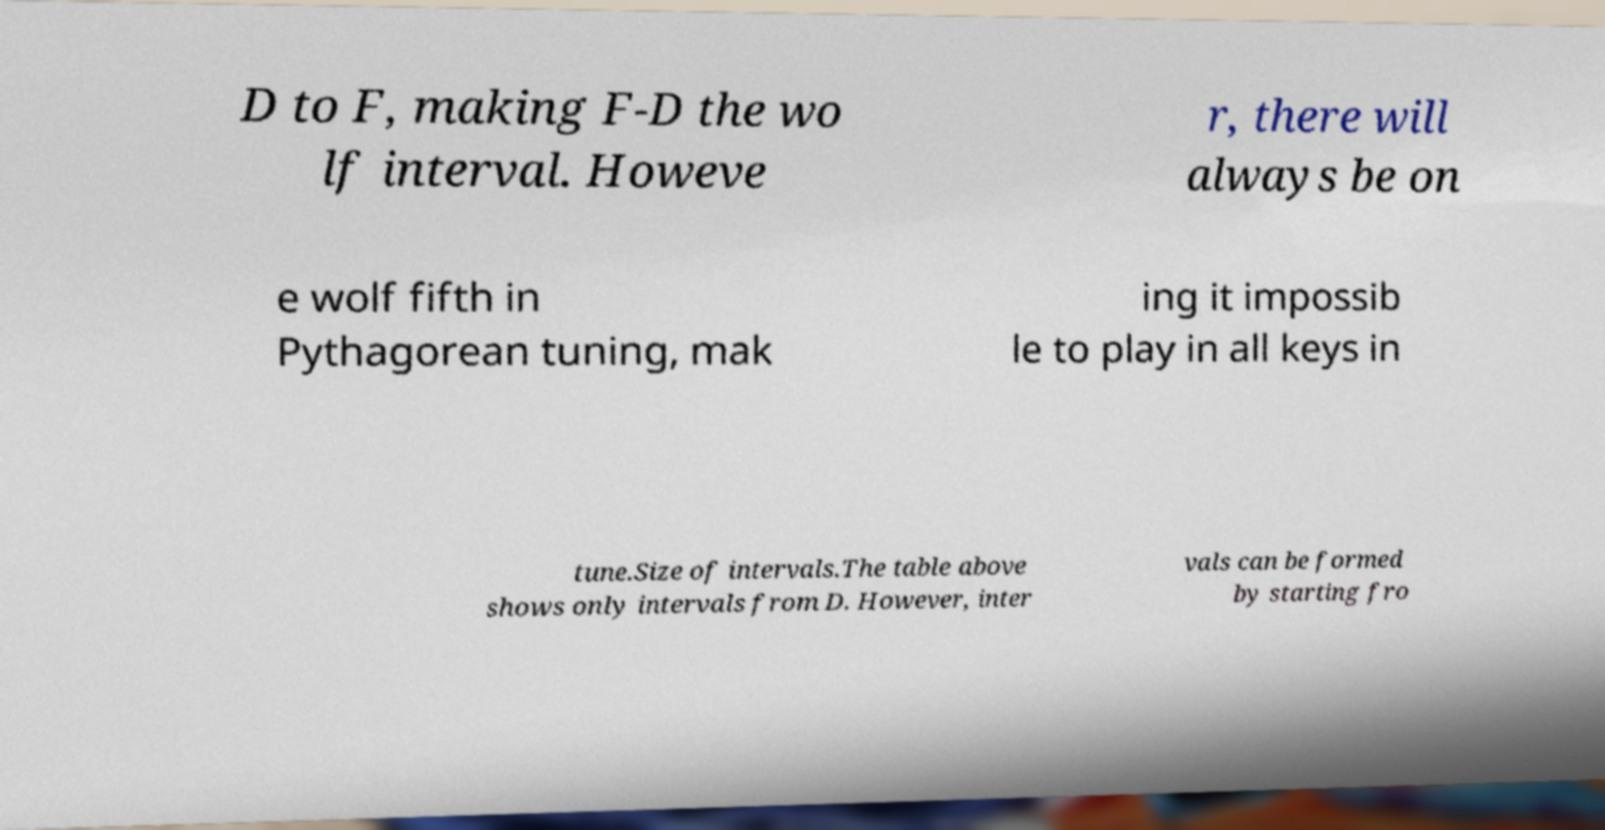What messages or text are displayed in this image? I need them in a readable, typed format. D to F, making F-D the wo lf interval. Howeve r, there will always be on e wolf fifth in Pythagorean tuning, mak ing it impossib le to play in all keys in tune.Size of intervals.The table above shows only intervals from D. However, inter vals can be formed by starting fro 